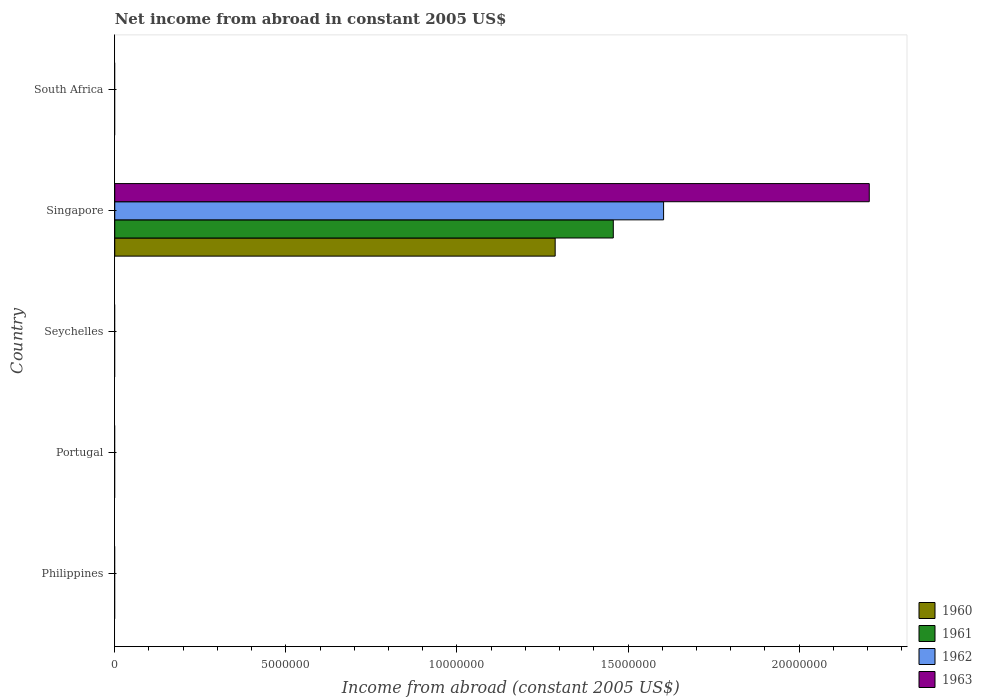Are the number of bars per tick equal to the number of legend labels?
Offer a very short reply. No. What is the label of the 5th group of bars from the top?
Offer a terse response. Philippines. In how many cases, is the number of bars for a given country not equal to the number of legend labels?
Keep it short and to the point. 4. Across all countries, what is the maximum net income from abroad in 1961?
Ensure brevity in your answer.  1.46e+07. Across all countries, what is the minimum net income from abroad in 1962?
Provide a succinct answer. 0. In which country was the net income from abroad in 1962 maximum?
Offer a terse response. Singapore. What is the total net income from abroad in 1960 in the graph?
Give a very brief answer. 1.29e+07. What is the difference between the net income from abroad in 1962 in Seychelles and the net income from abroad in 1960 in Singapore?
Offer a terse response. -1.29e+07. What is the average net income from abroad in 1960 per country?
Your answer should be compact. 2.57e+06. What is the difference between the net income from abroad in 1960 and net income from abroad in 1963 in Singapore?
Offer a very short reply. -9.18e+06. What is the difference between the highest and the lowest net income from abroad in 1962?
Make the answer very short. 1.60e+07. In how many countries, is the net income from abroad in 1962 greater than the average net income from abroad in 1962 taken over all countries?
Ensure brevity in your answer.  1. Is it the case that in every country, the sum of the net income from abroad in 1961 and net income from abroad in 1960 is greater than the sum of net income from abroad in 1962 and net income from abroad in 1963?
Make the answer very short. No. Is it the case that in every country, the sum of the net income from abroad in 1961 and net income from abroad in 1960 is greater than the net income from abroad in 1963?
Your answer should be very brief. No. Are all the bars in the graph horizontal?
Keep it short and to the point. Yes. Does the graph contain grids?
Your response must be concise. No. How many legend labels are there?
Provide a succinct answer. 4. What is the title of the graph?
Give a very brief answer. Net income from abroad in constant 2005 US$. What is the label or title of the X-axis?
Your answer should be compact. Income from abroad (constant 2005 US$). What is the label or title of the Y-axis?
Give a very brief answer. Country. What is the Income from abroad (constant 2005 US$) in 1960 in Philippines?
Provide a short and direct response. 0. What is the Income from abroad (constant 2005 US$) in 1961 in Philippines?
Give a very brief answer. 0. What is the Income from abroad (constant 2005 US$) in 1962 in Philippines?
Your response must be concise. 0. What is the Income from abroad (constant 2005 US$) in 1960 in Portugal?
Your answer should be very brief. 0. What is the Income from abroad (constant 2005 US$) in 1961 in Portugal?
Make the answer very short. 0. What is the Income from abroad (constant 2005 US$) of 1963 in Portugal?
Offer a very short reply. 0. What is the Income from abroad (constant 2005 US$) in 1962 in Seychelles?
Your response must be concise. 0. What is the Income from abroad (constant 2005 US$) of 1960 in Singapore?
Keep it short and to the point. 1.29e+07. What is the Income from abroad (constant 2005 US$) of 1961 in Singapore?
Give a very brief answer. 1.46e+07. What is the Income from abroad (constant 2005 US$) of 1962 in Singapore?
Ensure brevity in your answer.  1.60e+07. What is the Income from abroad (constant 2005 US$) in 1963 in Singapore?
Ensure brevity in your answer.  2.20e+07. What is the Income from abroad (constant 2005 US$) of 1960 in South Africa?
Your response must be concise. 0. What is the Income from abroad (constant 2005 US$) in 1961 in South Africa?
Keep it short and to the point. 0. What is the Income from abroad (constant 2005 US$) of 1962 in South Africa?
Offer a terse response. 0. Across all countries, what is the maximum Income from abroad (constant 2005 US$) in 1960?
Your answer should be very brief. 1.29e+07. Across all countries, what is the maximum Income from abroad (constant 2005 US$) in 1961?
Offer a terse response. 1.46e+07. Across all countries, what is the maximum Income from abroad (constant 2005 US$) in 1962?
Provide a short and direct response. 1.60e+07. Across all countries, what is the maximum Income from abroad (constant 2005 US$) in 1963?
Make the answer very short. 2.20e+07. Across all countries, what is the minimum Income from abroad (constant 2005 US$) of 1961?
Ensure brevity in your answer.  0. Across all countries, what is the minimum Income from abroad (constant 2005 US$) of 1962?
Your response must be concise. 0. Across all countries, what is the minimum Income from abroad (constant 2005 US$) in 1963?
Provide a short and direct response. 0. What is the total Income from abroad (constant 2005 US$) in 1960 in the graph?
Your answer should be very brief. 1.29e+07. What is the total Income from abroad (constant 2005 US$) of 1961 in the graph?
Give a very brief answer. 1.46e+07. What is the total Income from abroad (constant 2005 US$) of 1962 in the graph?
Give a very brief answer. 1.60e+07. What is the total Income from abroad (constant 2005 US$) in 1963 in the graph?
Your response must be concise. 2.20e+07. What is the average Income from abroad (constant 2005 US$) in 1960 per country?
Your response must be concise. 2.57e+06. What is the average Income from abroad (constant 2005 US$) of 1961 per country?
Offer a terse response. 2.91e+06. What is the average Income from abroad (constant 2005 US$) of 1962 per country?
Your answer should be compact. 3.21e+06. What is the average Income from abroad (constant 2005 US$) in 1963 per country?
Provide a succinct answer. 4.41e+06. What is the difference between the Income from abroad (constant 2005 US$) of 1960 and Income from abroad (constant 2005 US$) of 1961 in Singapore?
Keep it short and to the point. -1.70e+06. What is the difference between the Income from abroad (constant 2005 US$) of 1960 and Income from abroad (constant 2005 US$) of 1962 in Singapore?
Offer a very short reply. -3.17e+06. What is the difference between the Income from abroad (constant 2005 US$) of 1960 and Income from abroad (constant 2005 US$) of 1963 in Singapore?
Provide a short and direct response. -9.18e+06. What is the difference between the Income from abroad (constant 2005 US$) in 1961 and Income from abroad (constant 2005 US$) in 1962 in Singapore?
Your response must be concise. -1.47e+06. What is the difference between the Income from abroad (constant 2005 US$) in 1961 and Income from abroad (constant 2005 US$) in 1963 in Singapore?
Provide a succinct answer. -7.48e+06. What is the difference between the Income from abroad (constant 2005 US$) of 1962 and Income from abroad (constant 2005 US$) of 1963 in Singapore?
Your answer should be very brief. -6.01e+06. What is the difference between the highest and the lowest Income from abroad (constant 2005 US$) of 1960?
Your response must be concise. 1.29e+07. What is the difference between the highest and the lowest Income from abroad (constant 2005 US$) in 1961?
Your answer should be compact. 1.46e+07. What is the difference between the highest and the lowest Income from abroad (constant 2005 US$) in 1962?
Offer a very short reply. 1.60e+07. What is the difference between the highest and the lowest Income from abroad (constant 2005 US$) in 1963?
Make the answer very short. 2.20e+07. 